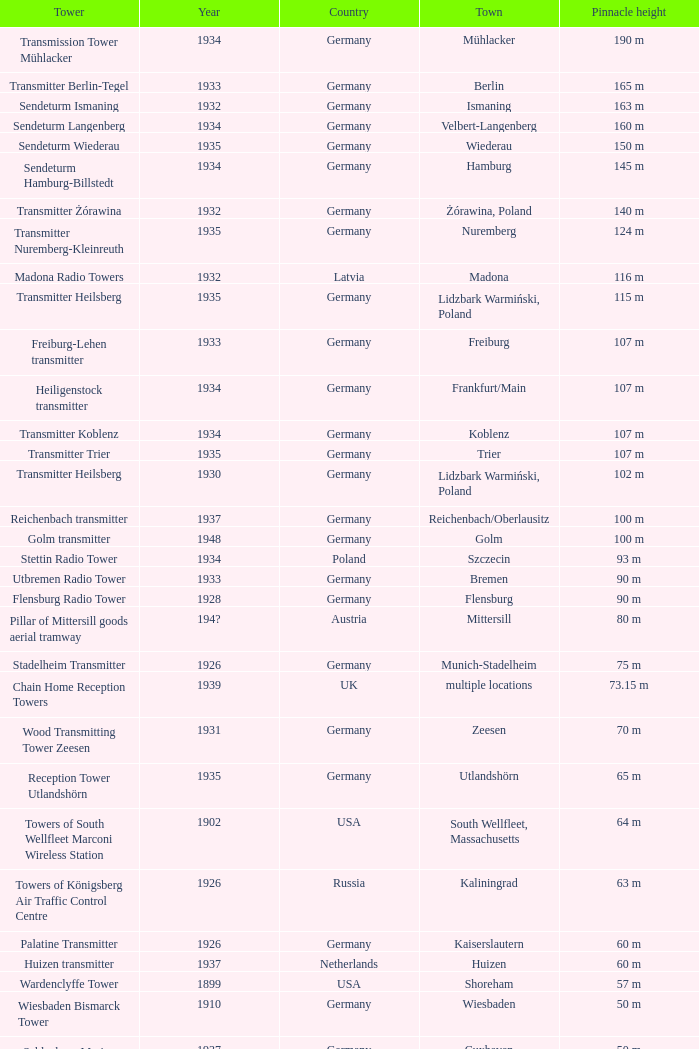In which country was a tower dismantled in 1899? USA. 